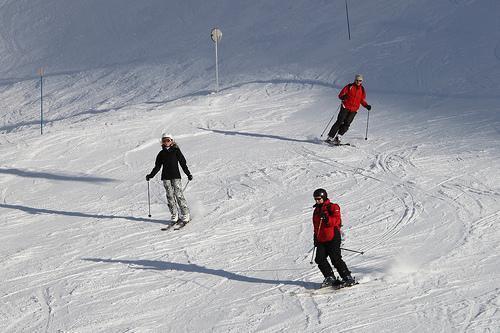How many people?
Give a very brief answer. 3. How many red color people are there in the image ?ok?
Give a very brief answer. 2. How many person in the image is wearing black color t-shirt?
Give a very brief answer. 1. 